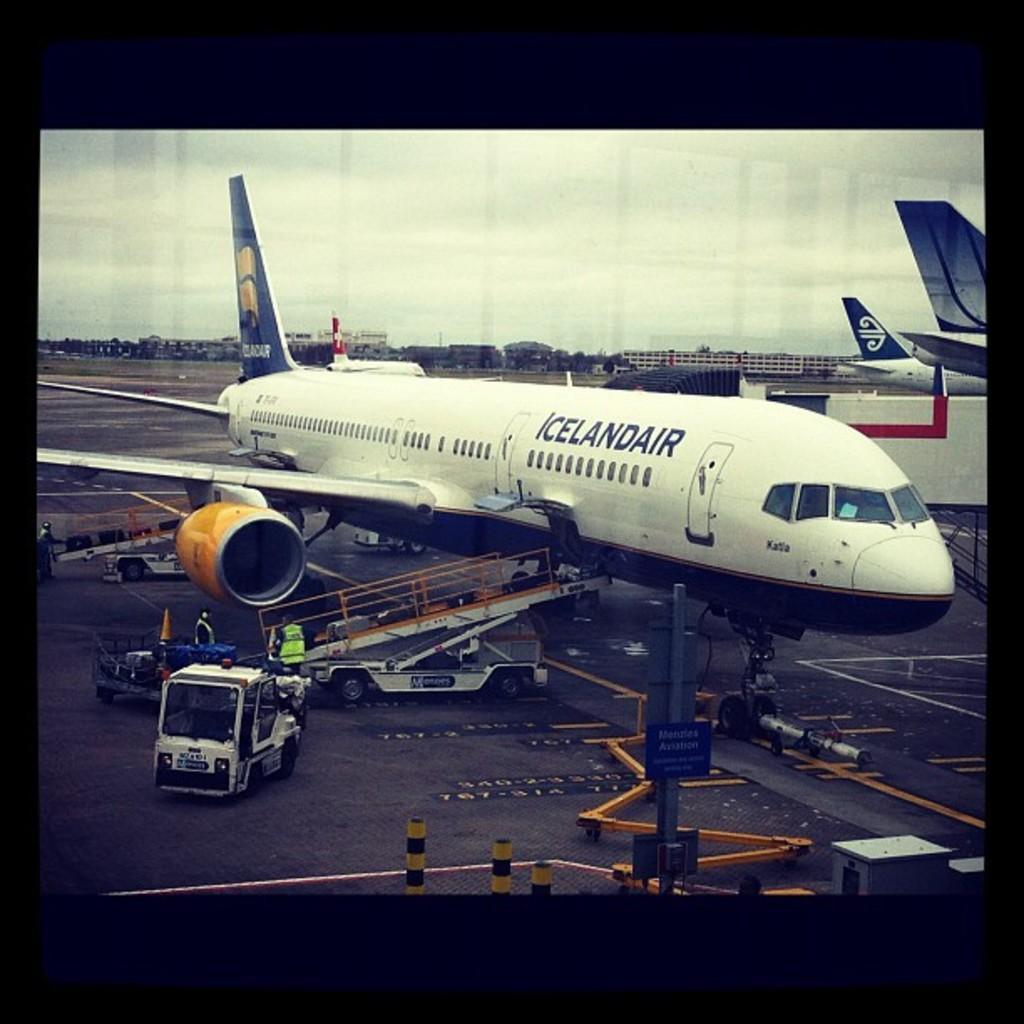How would you summarize this image in a sentence or two? In this image we can see aeroplanes and vehicles on the road and there are few persons and objects. In the background there are trees, buildings and clouds in the sky. 